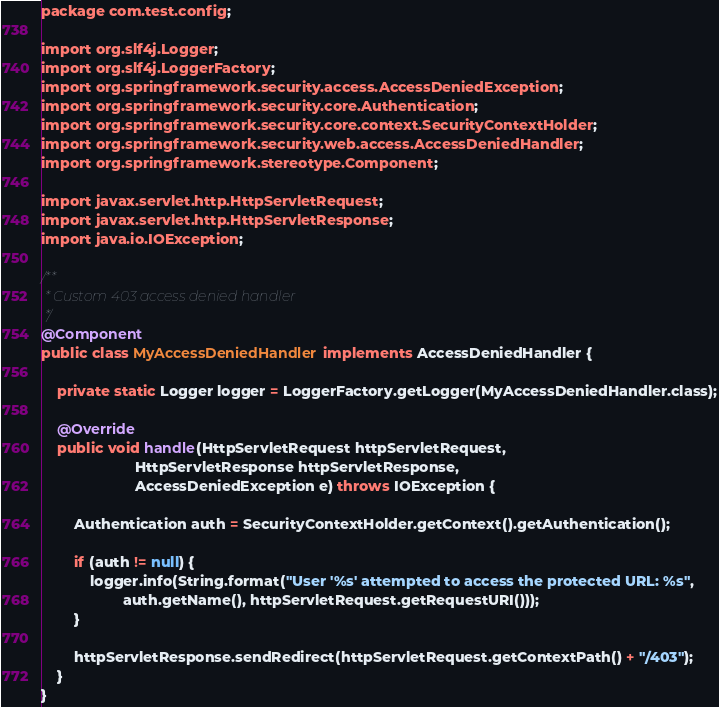<code> <loc_0><loc_0><loc_500><loc_500><_Java_>package com.test.config;

import org.slf4j.Logger;
import org.slf4j.LoggerFactory;
import org.springframework.security.access.AccessDeniedException;
import org.springframework.security.core.Authentication;
import org.springframework.security.core.context.SecurityContextHolder;
import org.springframework.security.web.access.AccessDeniedHandler;
import org.springframework.stereotype.Component;

import javax.servlet.http.HttpServletRequest;
import javax.servlet.http.HttpServletResponse;
import java.io.IOException;

/**
 * Custom 403 access denied handler
 */
@Component
public class MyAccessDeniedHandler implements AccessDeniedHandler {

    private static Logger logger = LoggerFactory.getLogger(MyAccessDeniedHandler.class);

    @Override
    public void handle(HttpServletRequest httpServletRequest,
                       HttpServletResponse httpServletResponse,
                       AccessDeniedException e) throws IOException {

        Authentication auth = SecurityContextHolder.getContext().getAuthentication();

        if (auth != null) {
            logger.info(String.format("User '%s' attempted to access the protected URL: %s",
                    auth.getName(), httpServletRequest.getRequestURI()));
        }

        httpServletResponse.sendRedirect(httpServletRequest.getContextPath() + "/403");
    }
}
</code> 